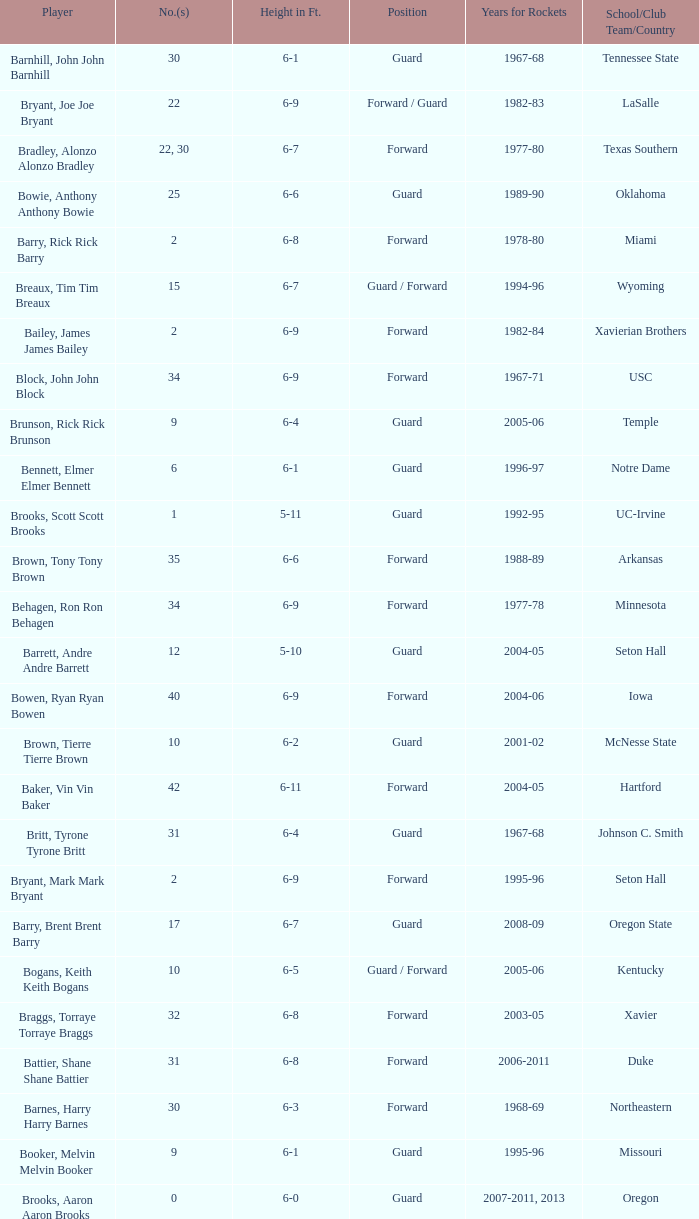What is the height of the player who attended Hartford? 6-11. 